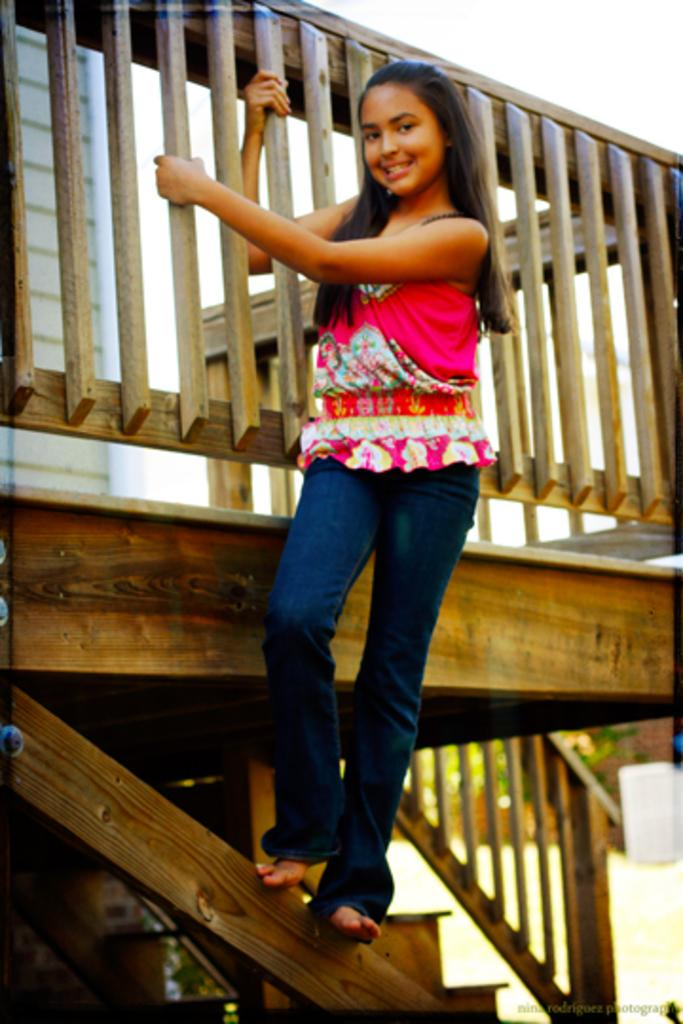What is the girl doing in the image? The girl is standing on a wooden stick in the image. What is connected to the wooden stick? There is a trailing (possibly a rope or a vine) in the image. What structure can be seen in the image? There is a house in the image. What type of vegetation is present in the image? There are plants in the image. What part of the natural environment is visible in the image? The sky is visible in the image. How would you describe the background of the image? The background of the image is blurred. How many firemen are holding kittens in the image? There are no firemen or kittens present in the image. 